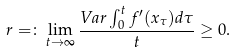<formula> <loc_0><loc_0><loc_500><loc_500>r = \colon \lim _ { t \rightarrow \infty } \frac { V a r \int _ { 0 } ^ { t } f ^ { \prime } ( x _ { \tau } ) d \tau } { t } \geq 0 .</formula> 